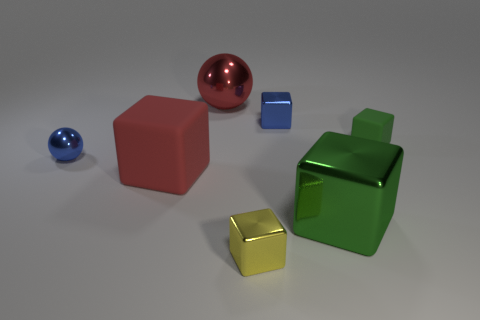Subtract all red cubes. How many cubes are left? 4 Subtract all red rubber cubes. How many cubes are left? 4 Subtract all red cubes. Subtract all gray balls. How many cubes are left? 4 Add 3 large red matte cubes. How many objects exist? 10 Subtract all cubes. How many objects are left? 2 Add 6 tiny green matte things. How many tiny green matte things are left? 7 Add 2 green shiny things. How many green shiny things exist? 3 Subtract 0 green spheres. How many objects are left? 7 Subtract all green blocks. Subtract all purple metal objects. How many objects are left? 5 